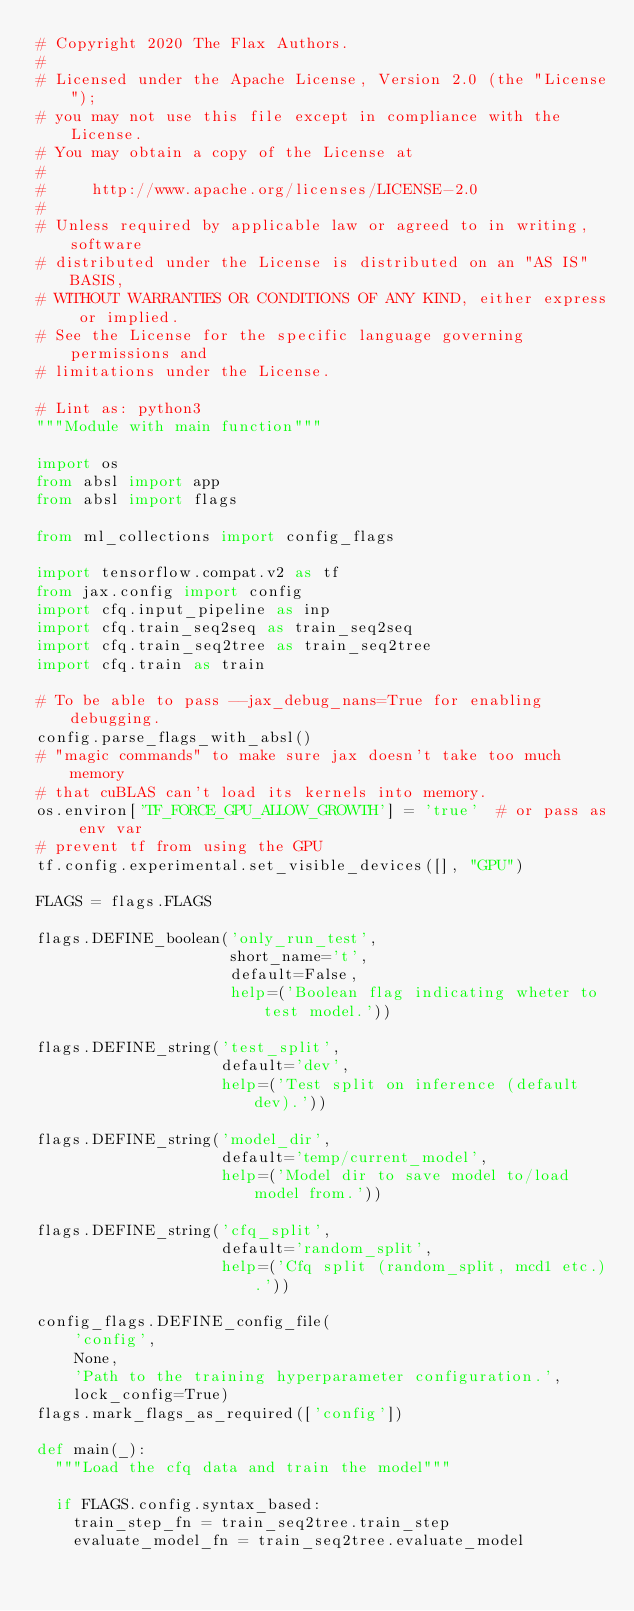Convert code to text. <code><loc_0><loc_0><loc_500><loc_500><_Python_># Copyright 2020 The Flax Authors.
#
# Licensed under the Apache License, Version 2.0 (the "License");
# you may not use this file except in compliance with the License.
# You may obtain a copy of the License at
#
#     http://www.apache.org/licenses/LICENSE-2.0
#
# Unless required by applicable law or agreed to in writing, software
# distributed under the License is distributed on an "AS IS" BASIS,
# WITHOUT WARRANTIES OR CONDITIONS OF ANY KIND, either express or implied.
# See the License for the specific language governing permissions and
# limitations under the License.

# Lint as: python3
"""Module with main function"""

import os
from absl import app
from absl import flags

from ml_collections import config_flags

import tensorflow.compat.v2 as tf
from jax.config import config
import cfq.input_pipeline as inp
import cfq.train_seq2seq as train_seq2seq
import cfq.train_seq2tree as train_seq2tree
import cfq.train as train

# To be able to pass --jax_debug_nans=True for enabling debugging.
config.parse_flags_with_absl()
# "magic commands" to make sure jax doesn't take too much memory
# that cuBLAS can't load its kernels into memory.
os.environ['TF_FORCE_GPU_ALLOW_GROWTH'] = 'true'  # or pass as env var
# prevent tf from using the GPU
tf.config.experimental.set_visible_devices([], "GPU")

FLAGS = flags.FLAGS

flags.DEFINE_boolean('only_run_test',
                     short_name='t',
                     default=False,
                     help=('Boolean flag indicating wheter to test model.'))

flags.DEFINE_string('test_split',
                    default='dev',
                    help=('Test split on inference (default dev).'))

flags.DEFINE_string('model_dir',
                    default='temp/current_model',
                    help=('Model dir to save model to/load model from.'))

flags.DEFINE_string('cfq_split',
                    default='random_split',
                    help=('Cfq split (random_split, mcd1 etc.).'))

config_flags.DEFINE_config_file(
    'config',
    None,
    'Path to the training hyperparameter configuration.',
    lock_config=True)
flags.mark_flags_as_required(['config'])

def main(_):
  """Load the cfq data and train the model"""

  if FLAGS.config.syntax_based:
    train_step_fn = train_seq2tree.train_step
    evaluate_model_fn = train_seq2tree.evaluate_model</code> 